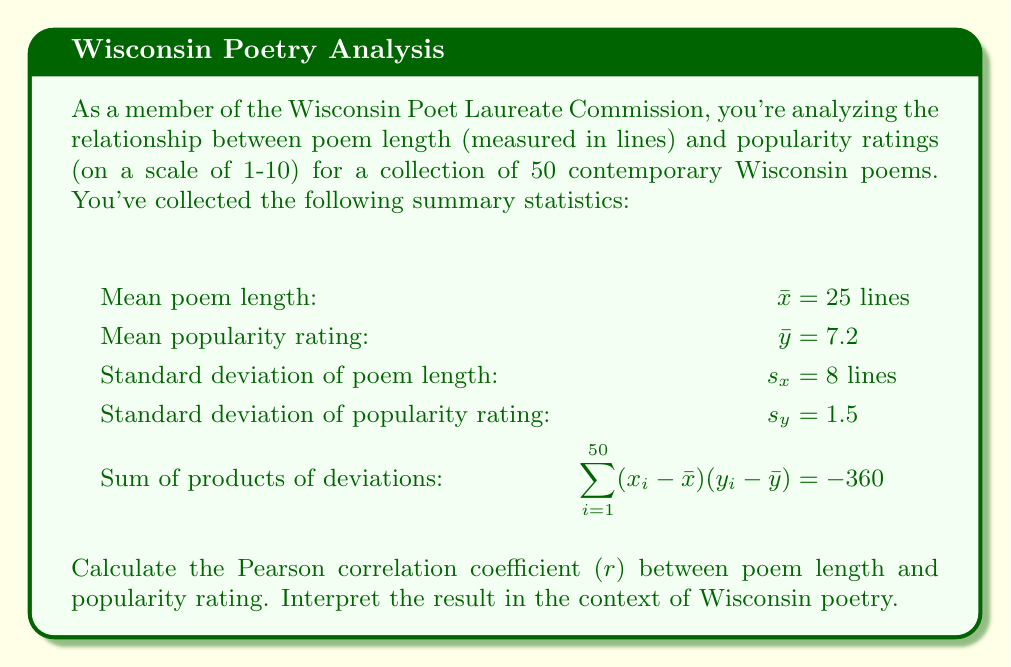Can you solve this math problem? To calculate the Pearson correlation coefficient $(r)$, we'll use the formula:

$$r = \frac{\sum_{i=1}^{n} (x_i - \bar{x})(y_i - \bar{y})}{(n-1)s_x s_y}$$

Where:
$n$ = number of poems = 50
$\sum_{i=1}^{50} (x_i - \bar{x})(y_i - \bar{y}) = -360$ (given)
$s_x = 8$ (given)
$s_y = 1.5$ (given)

Let's substitute these values into the formula:

$$r = \frac{-360}{(50-1)(8)(1.5)}$$

$$r = \frac{-360}{(49)(8)(1.5)}$$

$$r = \frac{-360}{588}$$

$$r \approx -0.6122$$

The correlation coefficient ranges from -1 to 1, where:
- -1 indicates a perfect negative linear relationship
- 0 indicates no linear relationship
- 1 indicates a perfect positive linear relationship

In this case, $r \approx -0.6122$, which indicates a moderate negative correlation between poem length and popularity rating.

Interpretation: In the context of Wisconsin poetry, this result suggests that, on average, shorter poems tend to be more popular among readers. As the length of a poem increases, its popularity rating tends to decrease. However, the relationship is not perfect, as indicated by the moderate strength of the correlation. Other factors likely influence a poem's popularity besides its length.
Answer: $r \approx -0.6122$, indicating a moderate negative correlation between poem length and popularity rating for Wisconsin poems. 